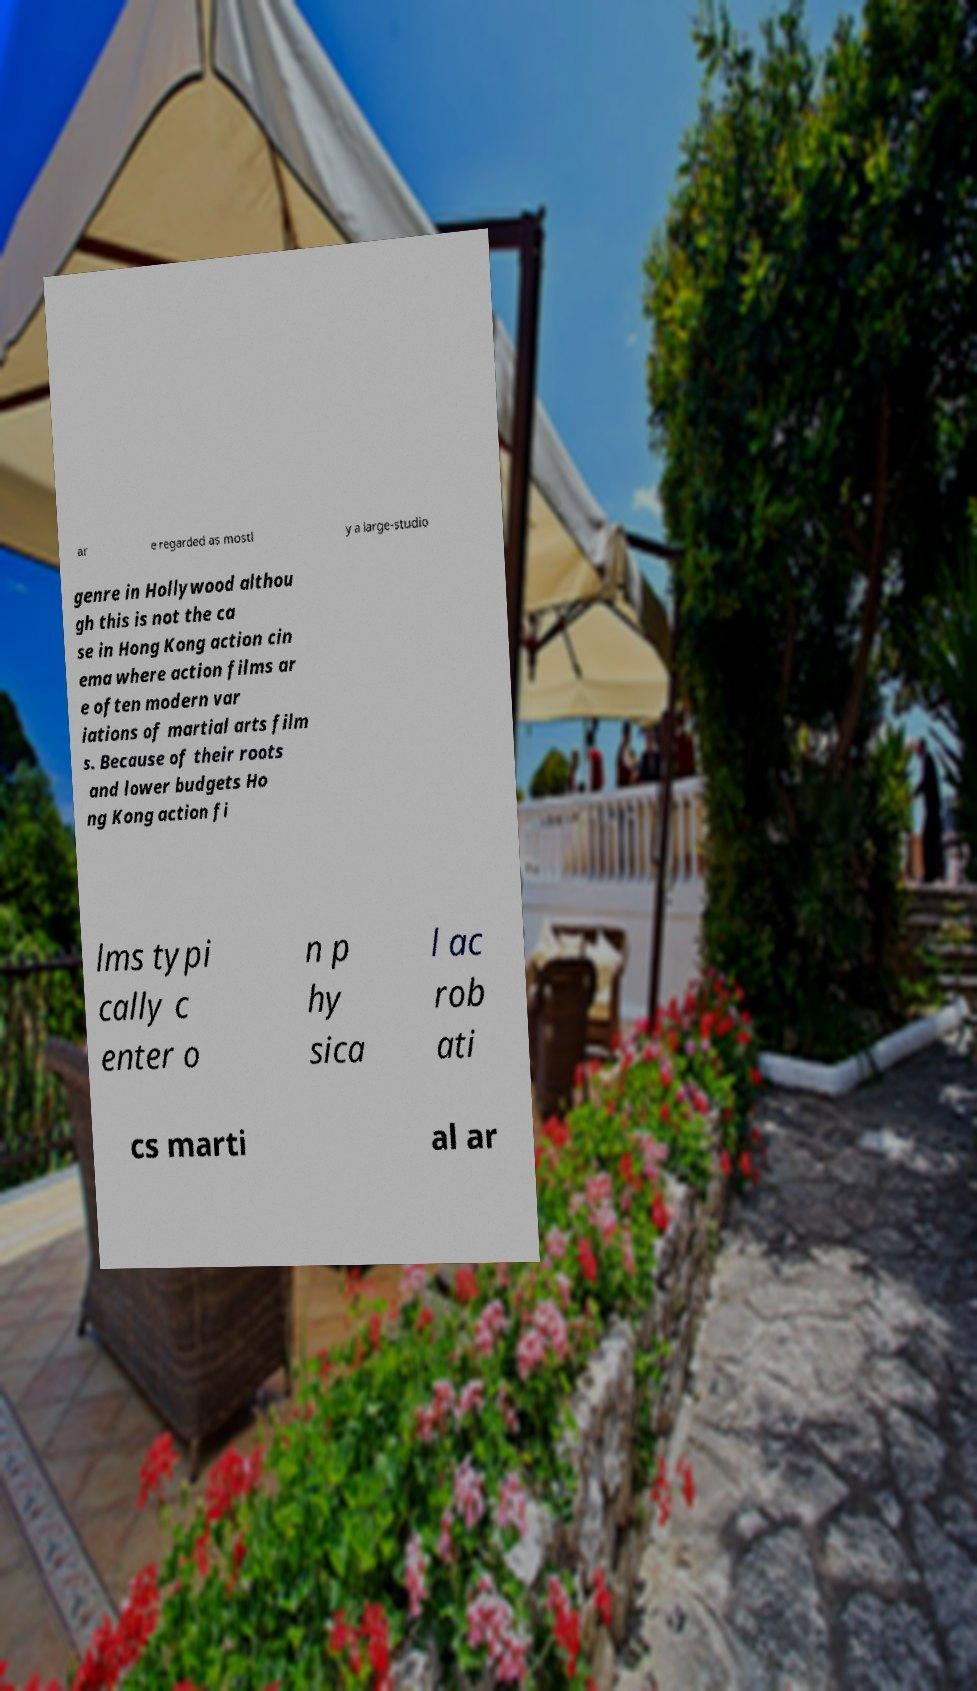There's text embedded in this image that I need extracted. Can you transcribe it verbatim? ar e regarded as mostl y a large-studio genre in Hollywood althou gh this is not the ca se in Hong Kong action cin ema where action films ar e often modern var iations of martial arts film s. Because of their roots and lower budgets Ho ng Kong action fi lms typi cally c enter o n p hy sica l ac rob ati cs marti al ar 